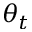Convert formula to latex. <formula><loc_0><loc_0><loc_500><loc_500>\theta _ { t }</formula> 